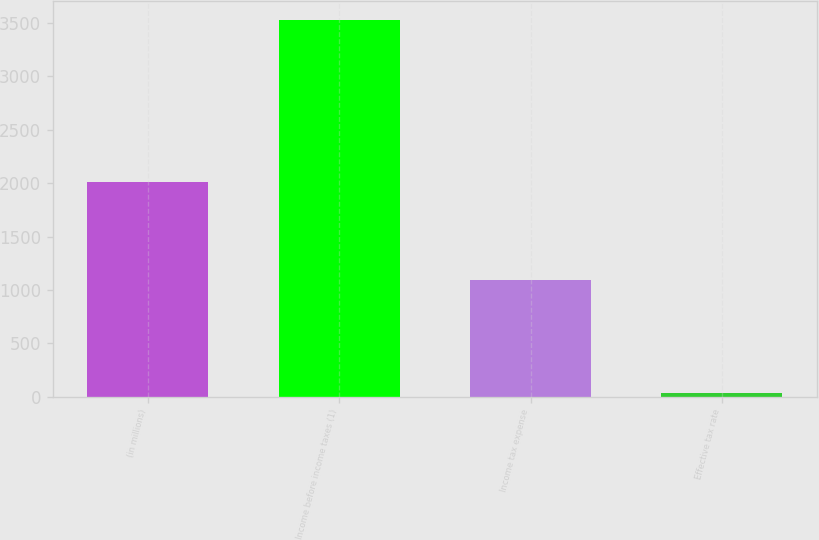<chart> <loc_0><loc_0><loc_500><loc_500><bar_chart><fcel>(in millions)<fcel>Income before income taxes (1)<fcel>Income tax expense<fcel>Effective tax rate<nl><fcel>2012<fcel>3532<fcel>1094<fcel>31<nl></chart> 